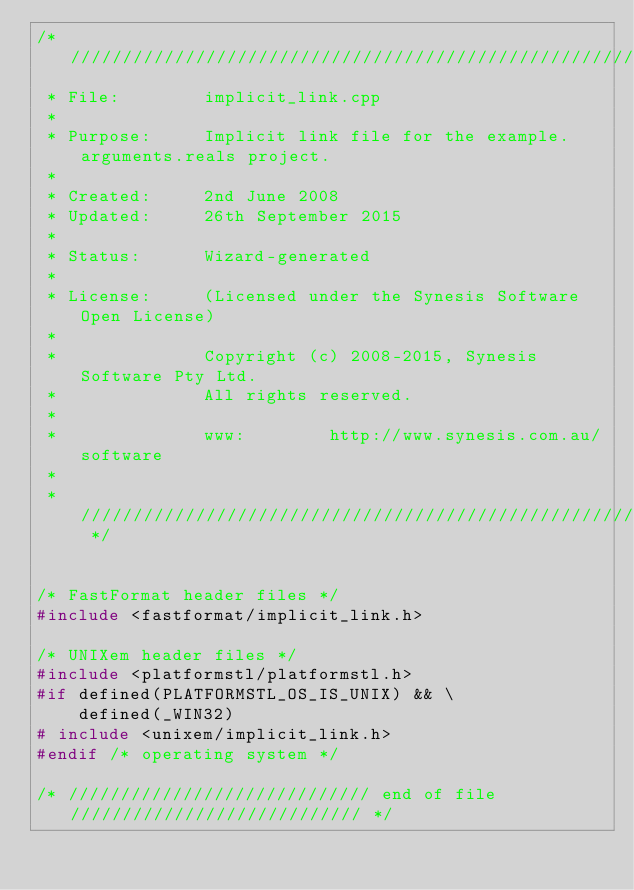Convert code to text. <code><loc_0><loc_0><loc_500><loc_500><_C++_>/* /////////////////////////////////////////////////////////////////////////
 * File:        implicit_link.cpp
 *
 * Purpose:     Implicit link file for the example.arguments.reals project.
 *
 * Created:     2nd June 2008
 * Updated:     26th September 2015
 *
 * Status:      Wizard-generated
 *
 * License:     (Licensed under the Synesis Software Open License)
 *
 *              Copyright (c) 2008-2015, Synesis Software Pty Ltd.
 *              All rights reserved.
 *
 *              www:        http://www.synesis.com.au/software
 *
 * ////////////////////////////////////////////////////////////////////// */


/* FastFormat header files */
#include <fastformat/implicit_link.h>

/* UNIXem header files */
#include <platformstl/platformstl.h>
#if defined(PLATFORMSTL_OS_IS_UNIX) && \
    defined(_WIN32)
# include <unixem/implicit_link.h>
#endif /* operating system */

/* ///////////////////////////// end of file //////////////////////////// */
</code> 